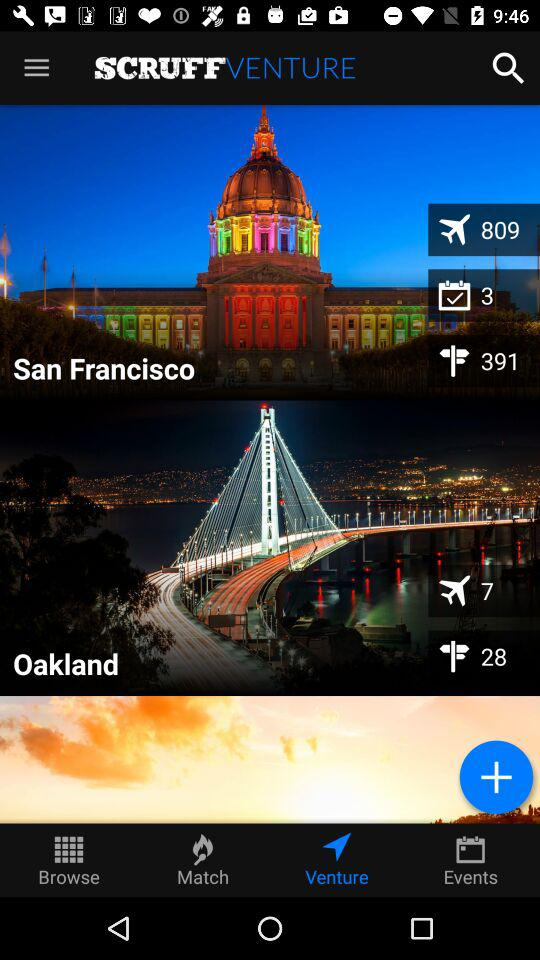What is the application name? The application name is "SCRUFF". 